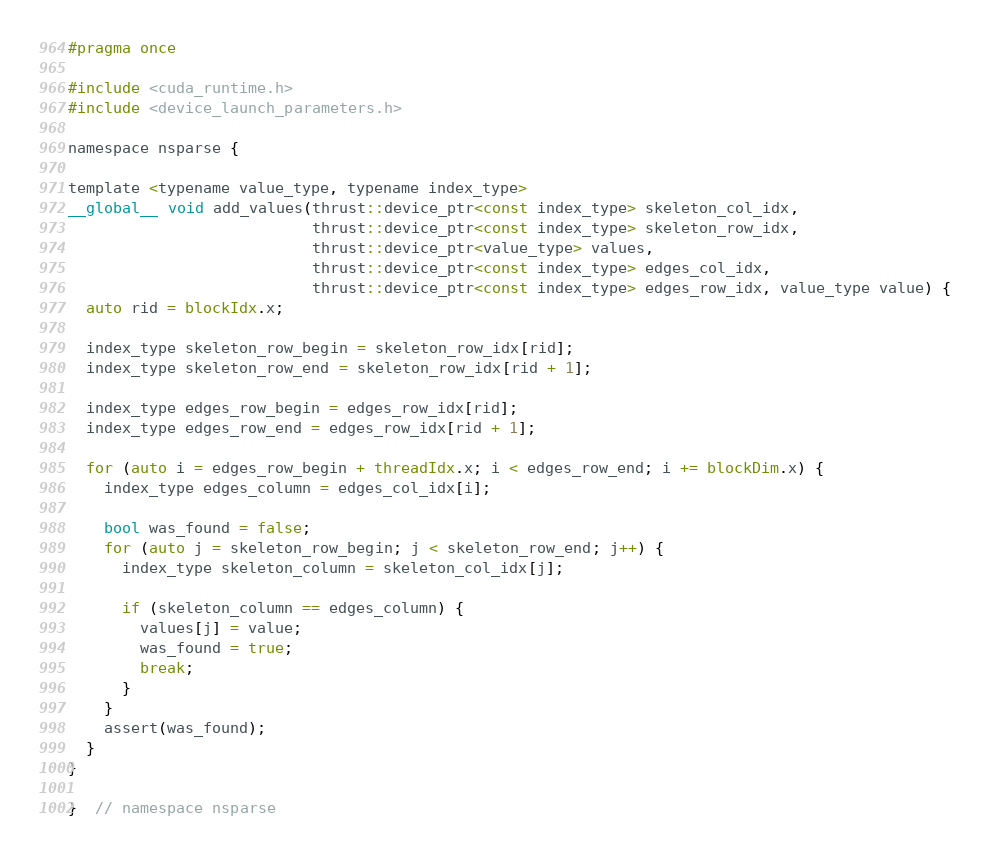Convert code to text. <code><loc_0><loc_0><loc_500><loc_500><_Cuda_>#pragma once

#include <cuda_runtime.h>
#include <device_launch_parameters.h>

namespace nsparse {

template <typename value_type, typename index_type>
__global__ void add_values(thrust::device_ptr<const index_type> skeleton_col_idx,
                           thrust::device_ptr<const index_type> skeleton_row_idx,
                           thrust::device_ptr<value_type> values,
                           thrust::device_ptr<const index_type> edges_col_idx,
                           thrust::device_ptr<const index_type> edges_row_idx, value_type value) {
  auto rid = blockIdx.x;

  index_type skeleton_row_begin = skeleton_row_idx[rid];
  index_type skeleton_row_end = skeleton_row_idx[rid + 1];

  index_type edges_row_begin = edges_row_idx[rid];
  index_type edges_row_end = edges_row_idx[rid + 1];

  for (auto i = edges_row_begin + threadIdx.x; i < edges_row_end; i += blockDim.x) {
    index_type edges_column = edges_col_idx[i];

    bool was_found = false;
    for (auto j = skeleton_row_begin; j < skeleton_row_end; j++) {
      index_type skeleton_column = skeleton_col_idx[j];

      if (skeleton_column == edges_column) {
        values[j] = value;
        was_found = true;
        break;
      }
    }
    assert(was_found);
  }
}

}  // namespace nsparse
</code> 